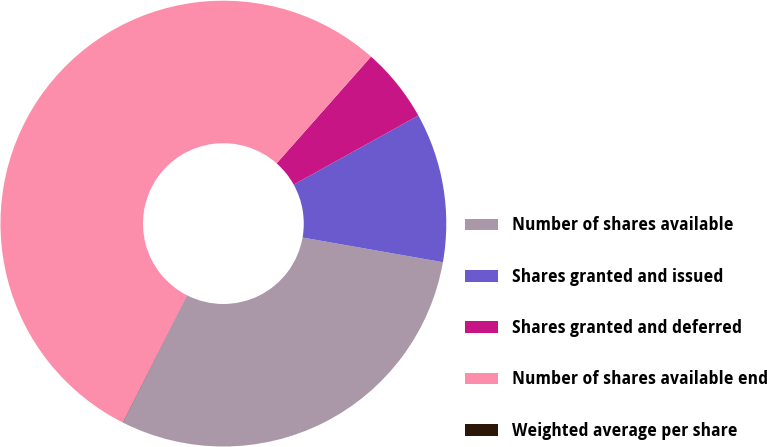<chart> <loc_0><loc_0><loc_500><loc_500><pie_chart><fcel>Number of shares available<fcel>Shares granted and issued<fcel>Shares granted and deferred<fcel>Number of shares available end<fcel>Weighted average per share<nl><fcel>29.66%<fcel>10.83%<fcel>5.42%<fcel>54.08%<fcel>0.02%<nl></chart> 